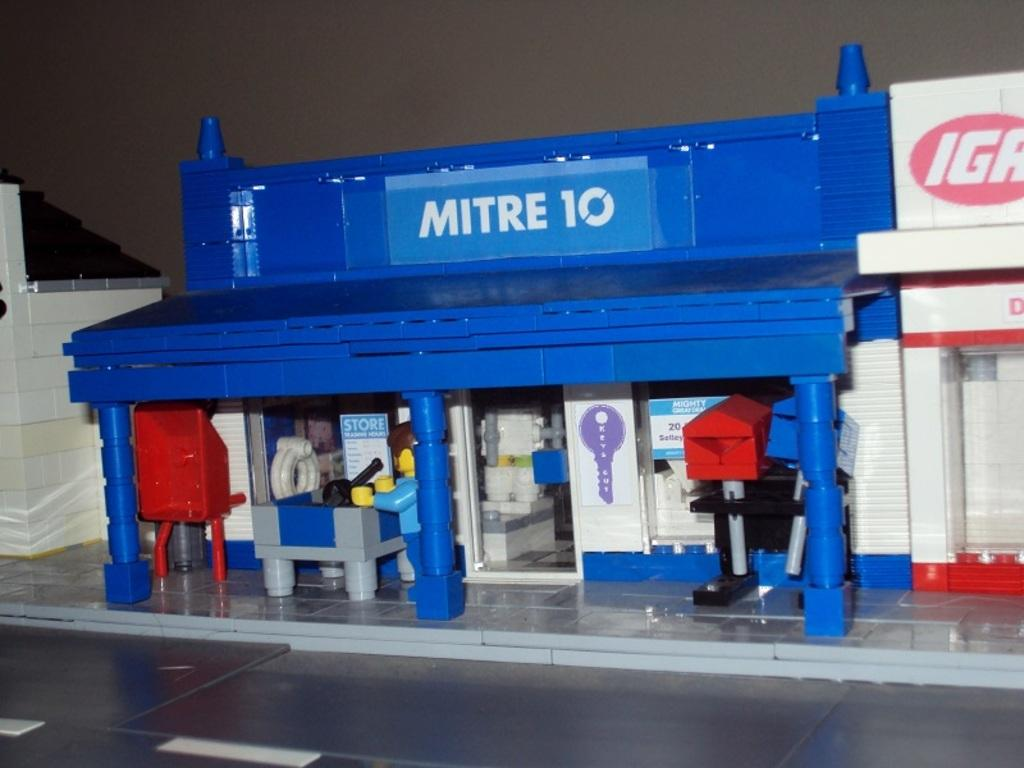What type of objects are built with legos in the image? There are crafts built with legos in the image. What is the surface on which the legos are placed? There is a floor at the bottom of the image. What can be seen in the background of the image? There is a wall in the background of the image. What type of stew is being prepared in the image? There is no stew present in the image; it features crafts built with legos. What type of stitch is used to create the crafts in the image? The crafts in the image are built with legos, not stitched, so there is no stitch used. 